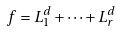<formula> <loc_0><loc_0><loc_500><loc_500>f = L _ { 1 } ^ { d } + \cdots + L _ { r } ^ { d }</formula> 